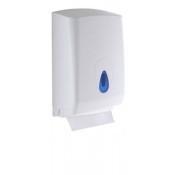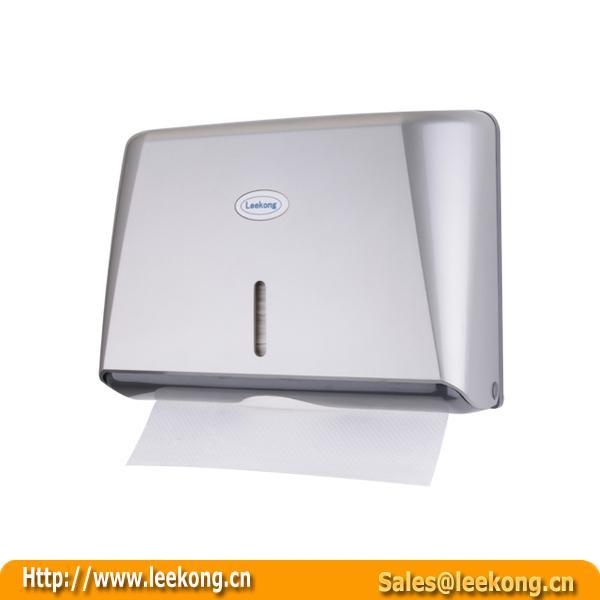The first image is the image on the left, the second image is the image on the right. For the images shown, is this caption "Each image shows a rectangular tray-type container holding a stack of folded paper towels." true? Answer yes or no. No. 